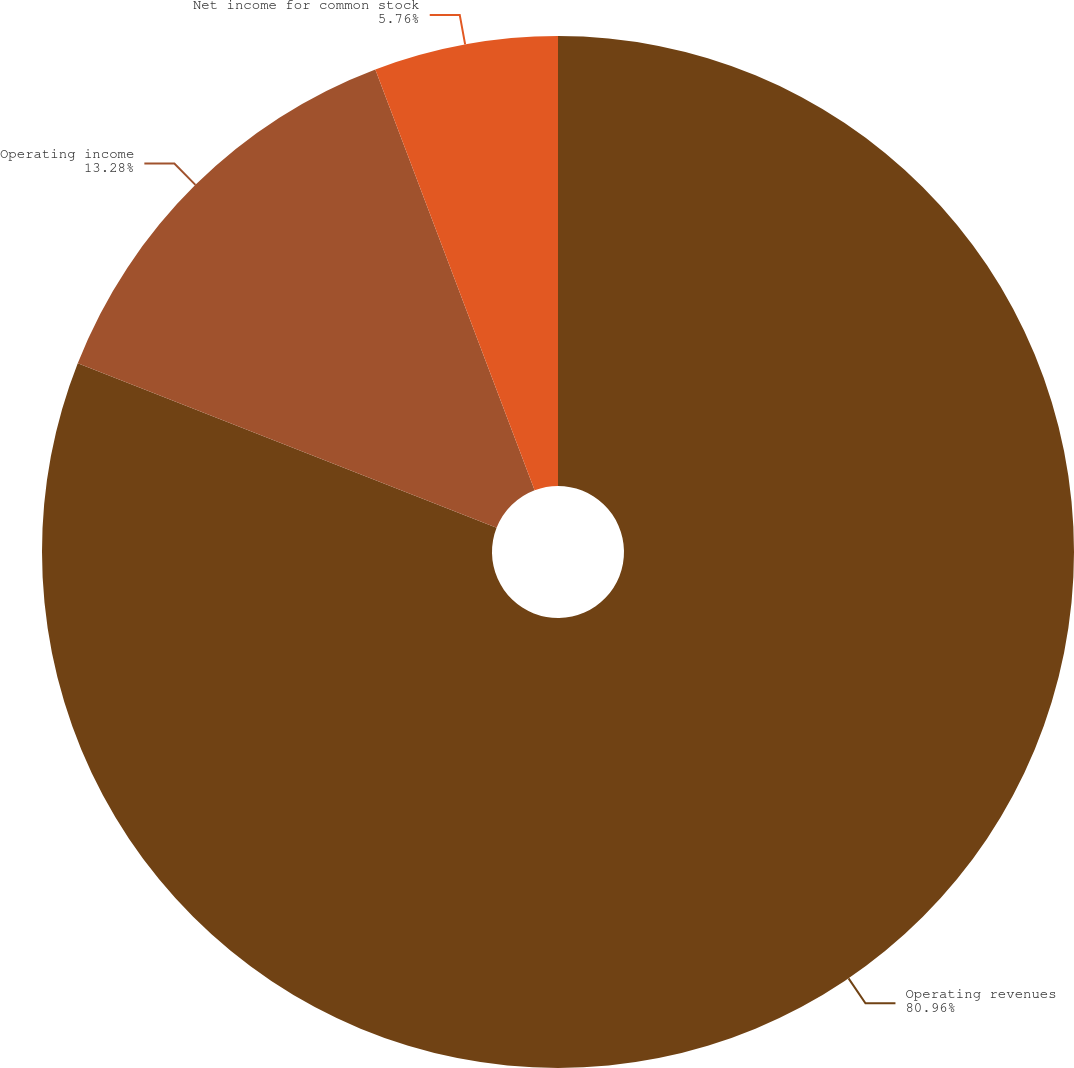<chart> <loc_0><loc_0><loc_500><loc_500><pie_chart><fcel>Operating revenues<fcel>Operating income<fcel>Net income for common stock<nl><fcel>80.96%<fcel>13.28%<fcel>5.76%<nl></chart> 